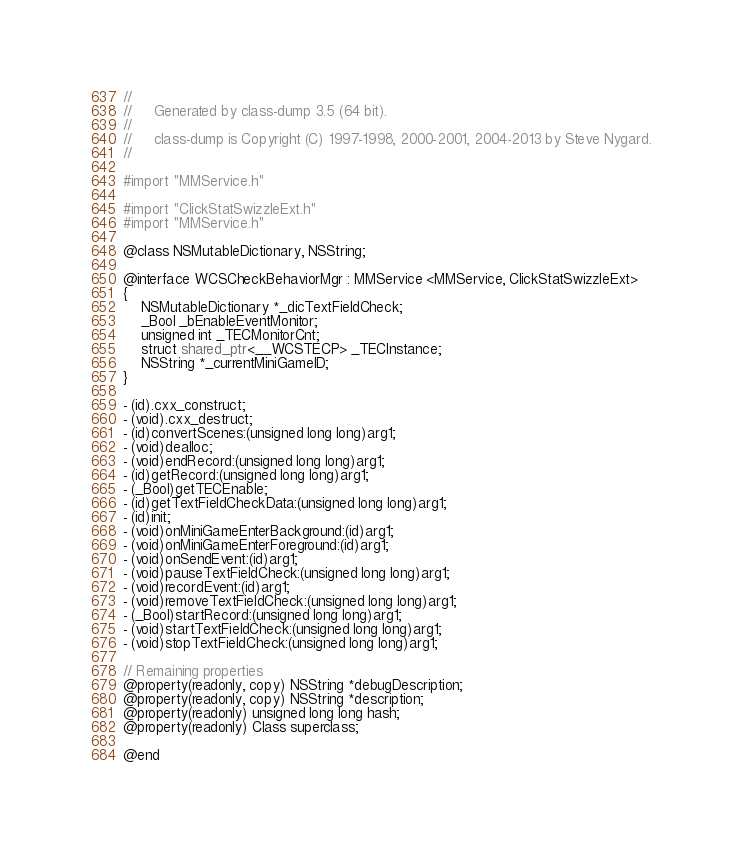Convert code to text. <code><loc_0><loc_0><loc_500><loc_500><_C_>//
//     Generated by class-dump 3.5 (64 bit).
//
//     class-dump is Copyright (C) 1997-1998, 2000-2001, 2004-2013 by Steve Nygard.
//

#import "MMService.h"

#import "ClickStatSwizzleExt.h"
#import "MMService.h"

@class NSMutableDictionary, NSString;

@interface WCSCheckBehaviorMgr : MMService <MMService, ClickStatSwizzleExt>
{
    NSMutableDictionary *_dicTextFieldCheck;
    _Bool _bEnableEventMonitor;
    unsigned int _TECMonitorCnt;
    struct shared_ptr<__WCSTECP> _TECInstance;
    NSString *_currentMiniGameID;
}

- (id).cxx_construct;
- (void).cxx_destruct;
- (id)convertScenes:(unsigned long long)arg1;
- (void)dealloc;
- (void)endRecord:(unsigned long long)arg1;
- (id)getRecord:(unsigned long long)arg1;
- (_Bool)getTECEnable;
- (id)getTextFieldCheckData:(unsigned long long)arg1;
- (id)init;
- (void)onMiniGameEnterBackground:(id)arg1;
- (void)onMiniGameEnterForeground:(id)arg1;
- (void)onSendEvent:(id)arg1;
- (void)pauseTextFieldCheck:(unsigned long long)arg1;
- (void)recordEvent:(id)arg1;
- (void)removeTextFieldCheck:(unsigned long long)arg1;
- (_Bool)startRecord:(unsigned long long)arg1;
- (void)startTextFieldCheck:(unsigned long long)arg1;
- (void)stopTextFieldCheck:(unsigned long long)arg1;

// Remaining properties
@property(readonly, copy) NSString *debugDescription;
@property(readonly, copy) NSString *description;
@property(readonly) unsigned long long hash;
@property(readonly) Class superclass;

@end

</code> 